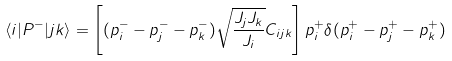Convert formula to latex. <formula><loc_0><loc_0><loc_500><loc_500>\langle i | P ^ { - } | j k \rangle = \left [ ( p _ { i } ^ { - } - p _ { j } ^ { - } - p _ { k } ^ { - } ) \sqrt { \frac { J _ { j } J _ { k } } { J _ { i } } } C _ { i j k } \right ] p _ { i } ^ { + } \delta ( p _ { i } ^ { + } - p _ { j } ^ { + } - p ^ { + } _ { k } )</formula> 